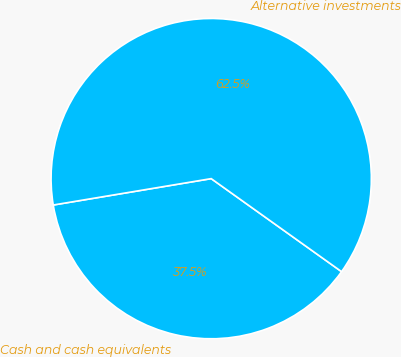Convert chart to OTSL. <chart><loc_0><loc_0><loc_500><loc_500><pie_chart><fcel>Cash and cash equivalents<fcel>Alternative investments<nl><fcel>37.5%<fcel>62.5%<nl></chart> 